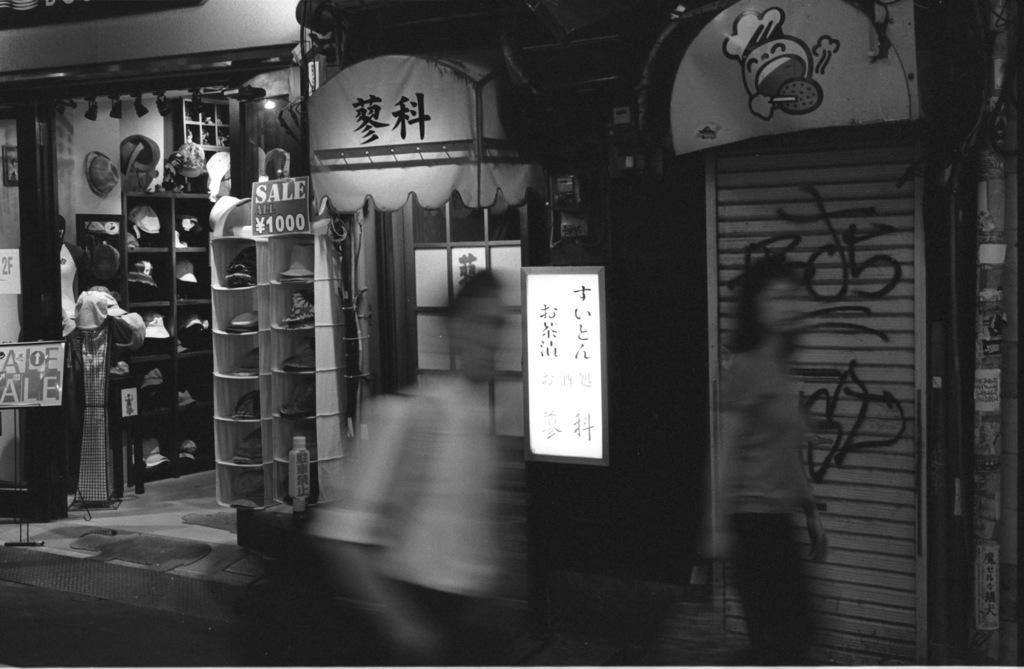Describe this image in one or two sentences. This is a black and white image and here we can see people. In the background, there are boards and there is a store with some stands and some caps in the racks and there are some other objects and we can see lights. At the bottom, there is a road and a floor. 